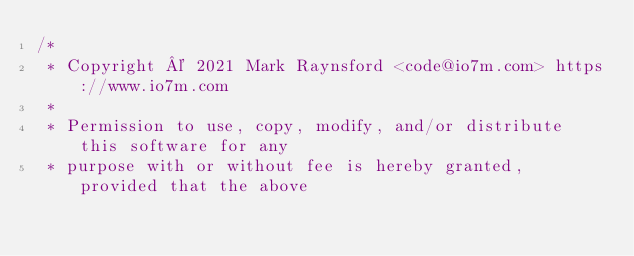<code> <loc_0><loc_0><loc_500><loc_500><_Java_>/*
 * Copyright © 2021 Mark Raynsford <code@io7m.com> https://www.io7m.com
 *
 * Permission to use, copy, modify, and/or distribute this software for any
 * purpose with or without fee is hereby granted, provided that the above</code> 